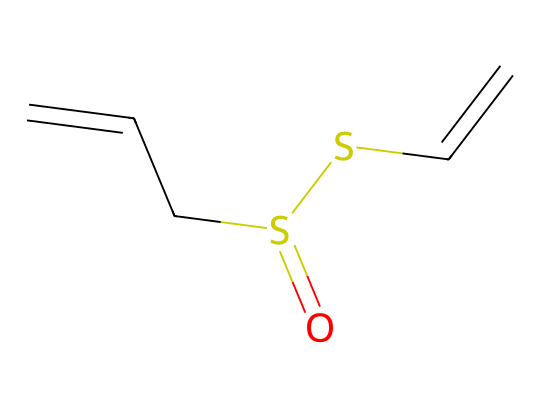What is the total number of carbon atoms in the chemical structure? By examining the SMILES representation, we identify the segments labeled with 'C', which are indications of carbon atoms. In this structure, there are five 'C' atoms in total.
Answer: 5 What type of functional group is present in this compound? The presence of the sulfur atom ('S') connected to oxygen ('O') and carbon ('C') indicates that this compound contains a sulfenic group, characteristic of organosulfur compounds.
Answer: sulfenic group How many double bonds are present in the structure? In the given SMILES representation, we see double bonds indicated directly by '=' symbols. Here, there are two double bonds involving carbon-carbon connections.
Answer: 2 What is the molecular formula for this compound? By adding up the atoms indicated in the SMILES (O, S, and C), we can create the molecular formula. There are 5 carbons, 2 sulfurs, and 1 oxygen, resulting in the formula C5H8S2O.
Answer: C5H8S2O Which part of the molecule is related to its cardiovascular health properties? The sulfur-containing functional groups in organosulfur compounds like allicin have been studied for their antioxidant properties and ability to affect cardiovascular health, particularly in reducing stress.
Answer: sulfur-containing functional groups What is the significance of the arrangement of carbon atoms? The arrangement of carbon atoms contributes to the geometry of the molecule, influencing reactivity and biological activity, particularly its ability to interact with enzymes and receptors related to cardiovascular function.
Answer: geometry of the molecule How does the presence of sulfur affect the reactivity of this compound? Sulfur’s electronegativity and its ability to form various types of bonds (like thiol and sulfonyl) enhance the reactivity of organosulfur compounds, enabling them to participate in biological processes related to cardiovascular health.
Answer: enhances reactivity 